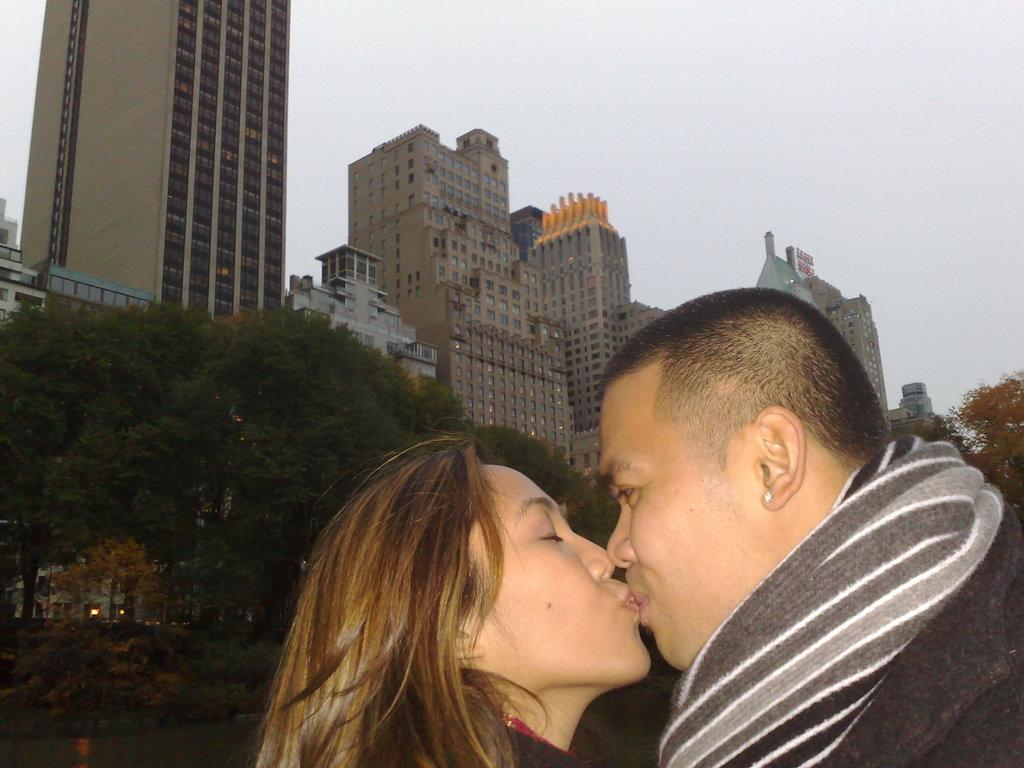How many people are present in the image? There are two people, a man and a woman, present in the image. What are the man and woman doing in the image? The man and woman are kissing in the image. What can be seen in the background of the image? There are trees, buildings, and the sky visible in the background of the image. Can you see any ducks in the image? There are no ducks present in the image. What part of the woman's elbow is visible in the image? The image does not show any specific part of the woman's elbow, as it focuses on the man and woman kissing. 